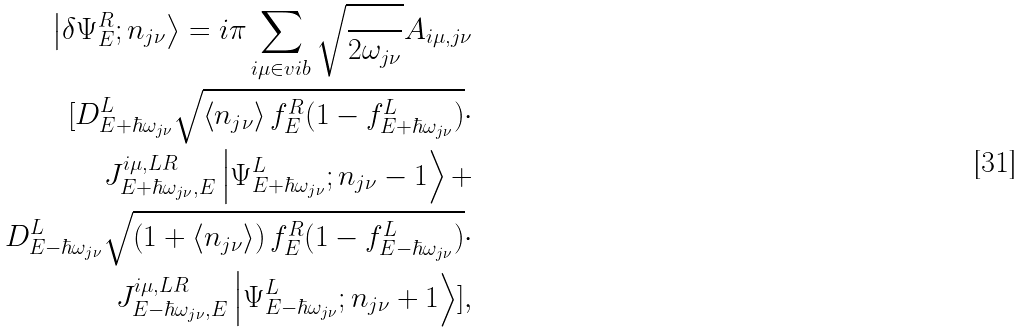<formula> <loc_0><loc_0><loc_500><loc_500>\left | \delta \Psi _ { E } ^ { R } ; n _ { j \nu } \right \rangle = i \pi \sum _ { i \mu \in v i b } \sqrt { \frac { } { 2 \omega _ { j \nu } } } A _ { i \mu , j \nu } \\ [ D _ { E + \hbar { \omega } _ { j \nu } } ^ { L } \sqrt { \left \langle n _ { j \nu } \right \rangle f _ { E } ^ { R } ( 1 - f _ { E + \hbar { \omega } _ { j \nu } } ^ { L } ) } \cdot \\ J _ { E + \hbar { \omega } _ { j \nu } , E } ^ { i \mu , L R } \left | \Psi _ { E + \hbar { \omega } _ { j \nu } } ^ { L } ; n _ { j \nu } - 1 \right \rangle + \\ D _ { E - \hbar { \omega } _ { j \nu } } ^ { L } \sqrt { \left ( 1 + \left \langle n _ { j \nu } \right \rangle \right ) f _ { E } ^ { R } ( 1 - f _ { E - \hbar { \omega } _ { j \nu } } ^ { L } ) } \cdot \\ J _ { E - \hbar { \omega } _ { j \nu } , E } ^ { i \mu , L R } \left | \Psi _ { E - \hbar { \omega } _ { j \nu } } ^ { L } ; n _ { j \nu } + 1 \right \rangle ] ,</formula> 